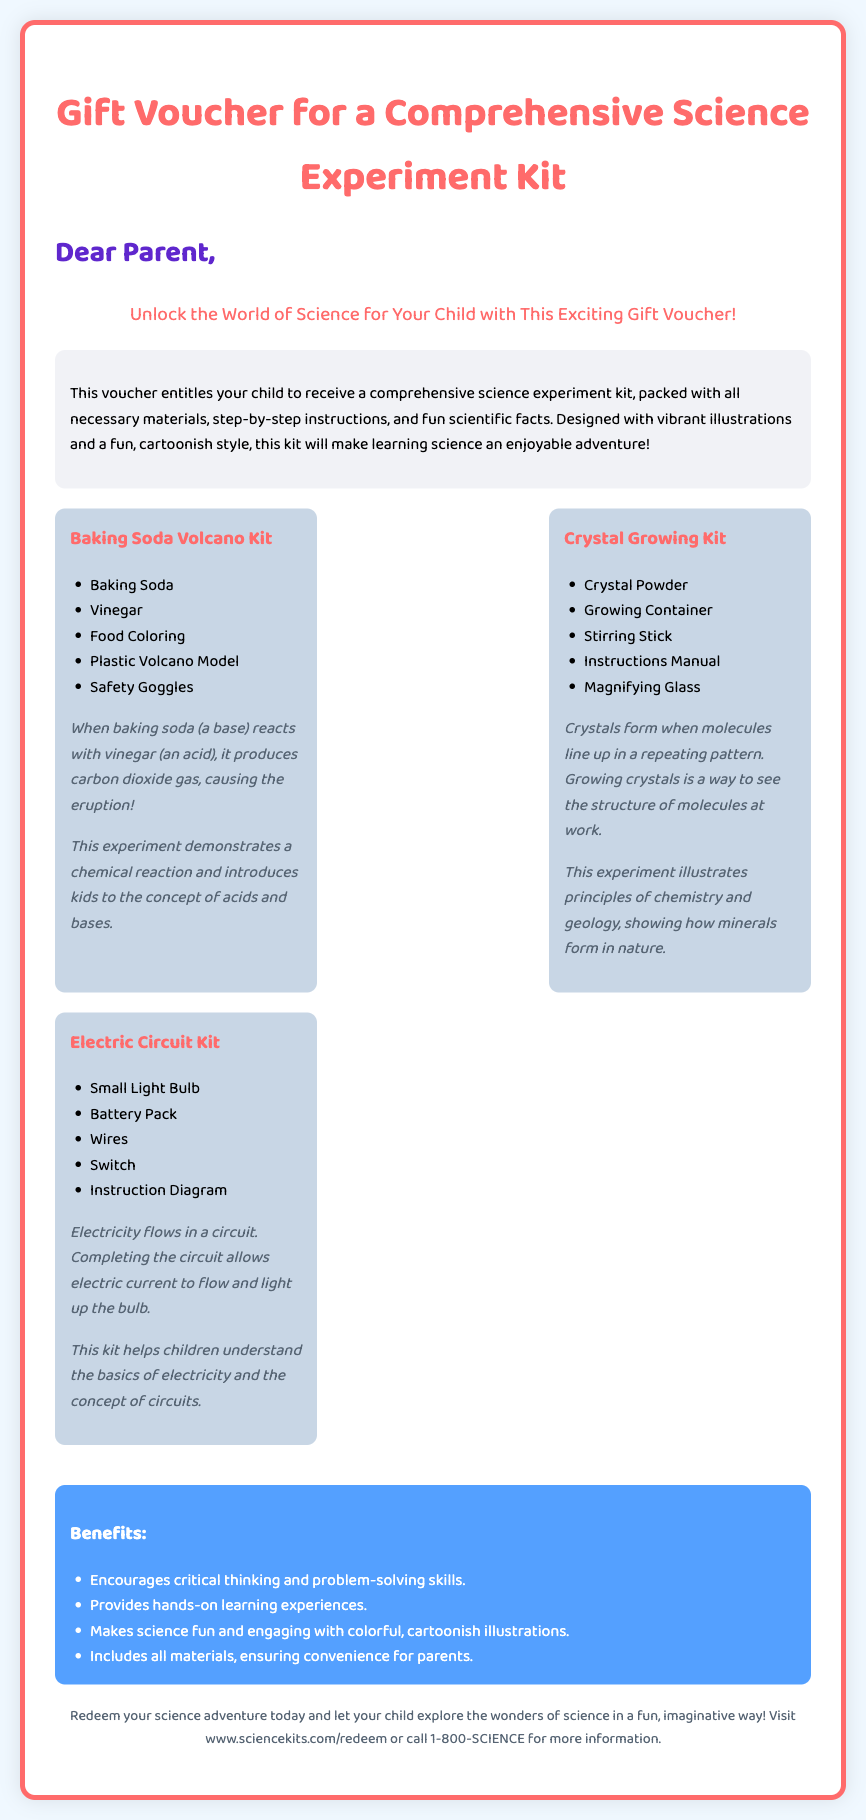What is the title of the gift voucher? The title of the gift voucher is stated at the top of the document.
Answer: Gift Voucher for a Comprehensive Science Experiment Kit Who is the intended recipient of the gift voucher? The intended recipient is mentioned in the greeting section of the document.
Answer: Your child How many kits are included in the science experiment kit? The document lists three specific kits within the kit's inclusions.
Answer: Three What is one of the materials included in the Baking Soda Volcano Kit? The document lists materials for the Baking Soda Volcano Kit.
Answer: Baking Soda What principle does crystal growing illustrate? The scientific fact underneath the Crystal Growing Kit mentions the principle it illustrates.
Answer: Chemistry and geology What is the main benefit of using this science experiment kit? The benefits are listed under a specific section in the document.
Answer: Encourages critical thinking and problem-solving skills Where can the voucher be redeemed? The footer of the document provides a website for redemption.
Answer: www.sciencekits.com/redeem What type of style is the kit designed with? The description section highlights the design style of the kit.
Answer: Cartoonish style What color scheme is used for the header of the voucher? The header color is explicitly mentioned in the styling details in the document.
Answer: #ff6b6b 